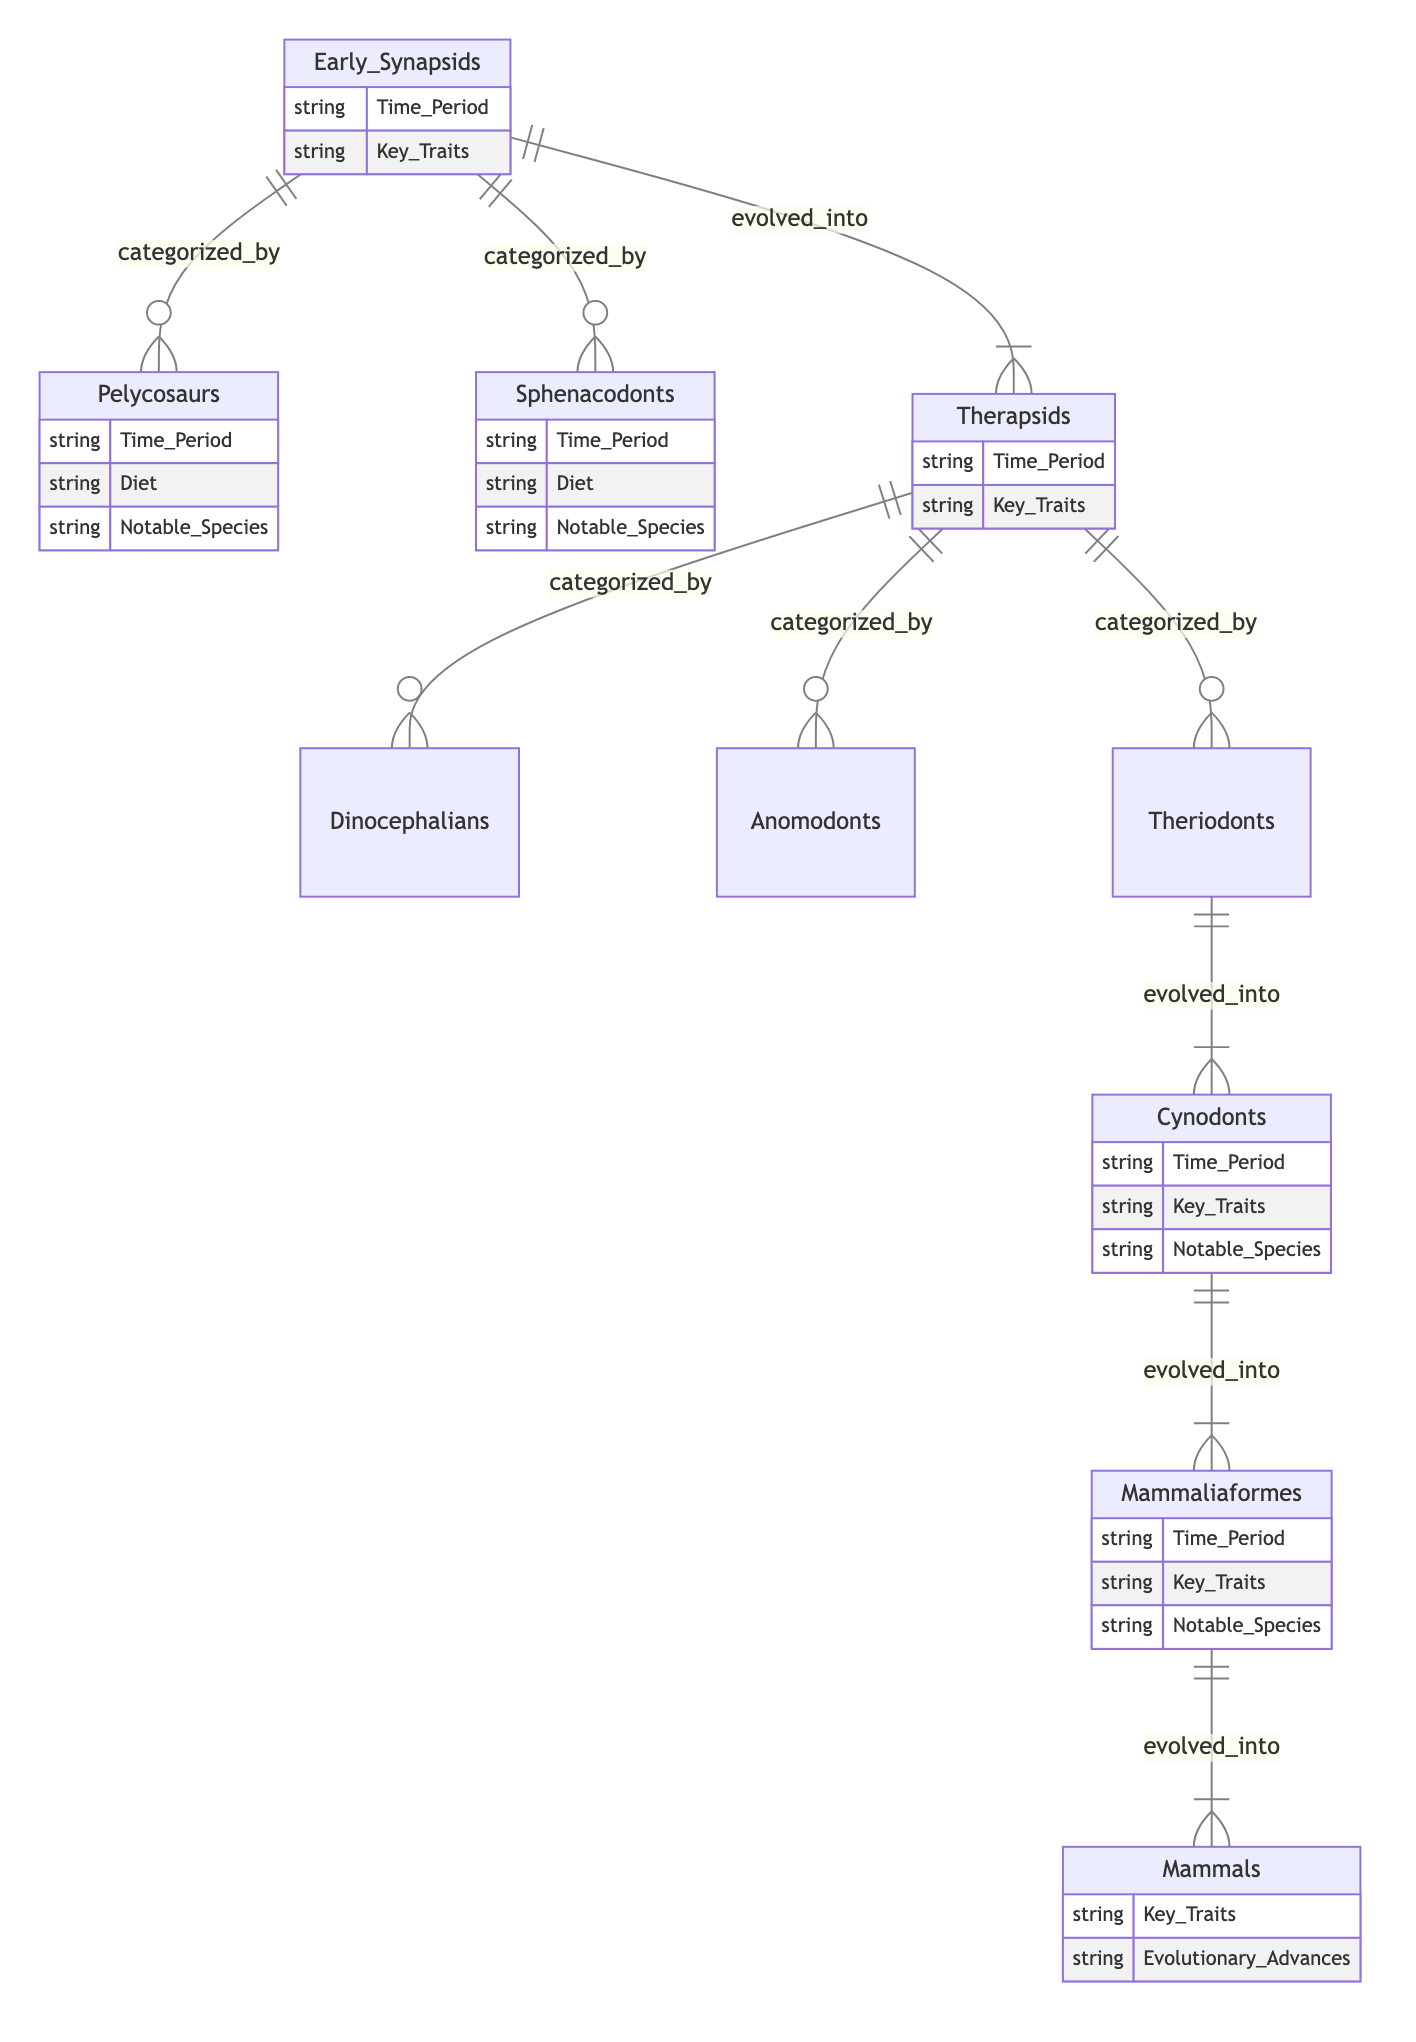What category do Pelycosaurs belong to? Pelycosaurs are categorized under Early Synapsids in the diagram. This relationship is illustrated as "categorized_by".
Answer: Early Synapsids How many types of Therapsids are listed? The diagram shows that there are three types of Therapsids: Dinocephalians, Anomodonts, and Theriodonts. This can be confirmed by counting the relationships branching from Therapsids.
Answer: 3 Which entity evolved into Mammaliaformes? The diagram shows that Cynodonts evolved into Mammaliaformes. This is indicated by the "evolved_into" relationship connecting the two entities.
Answer: Cynodonts What are the notable species mentioned under Cynodonts? According to the diagram, the notable species under Cynodonts are Procynosuchus and Thrinaxodon. This information is listed as examples under the Cynodonts entity.
Answer: Procynosuchus, Thrinaxodon What is the key trait of Mammals? The diagram indicates that Mammals possess key traits, although it does not specify what they specifically are. It serves to highlight that Mammals have specific advantages.
Answer: Key Traits 